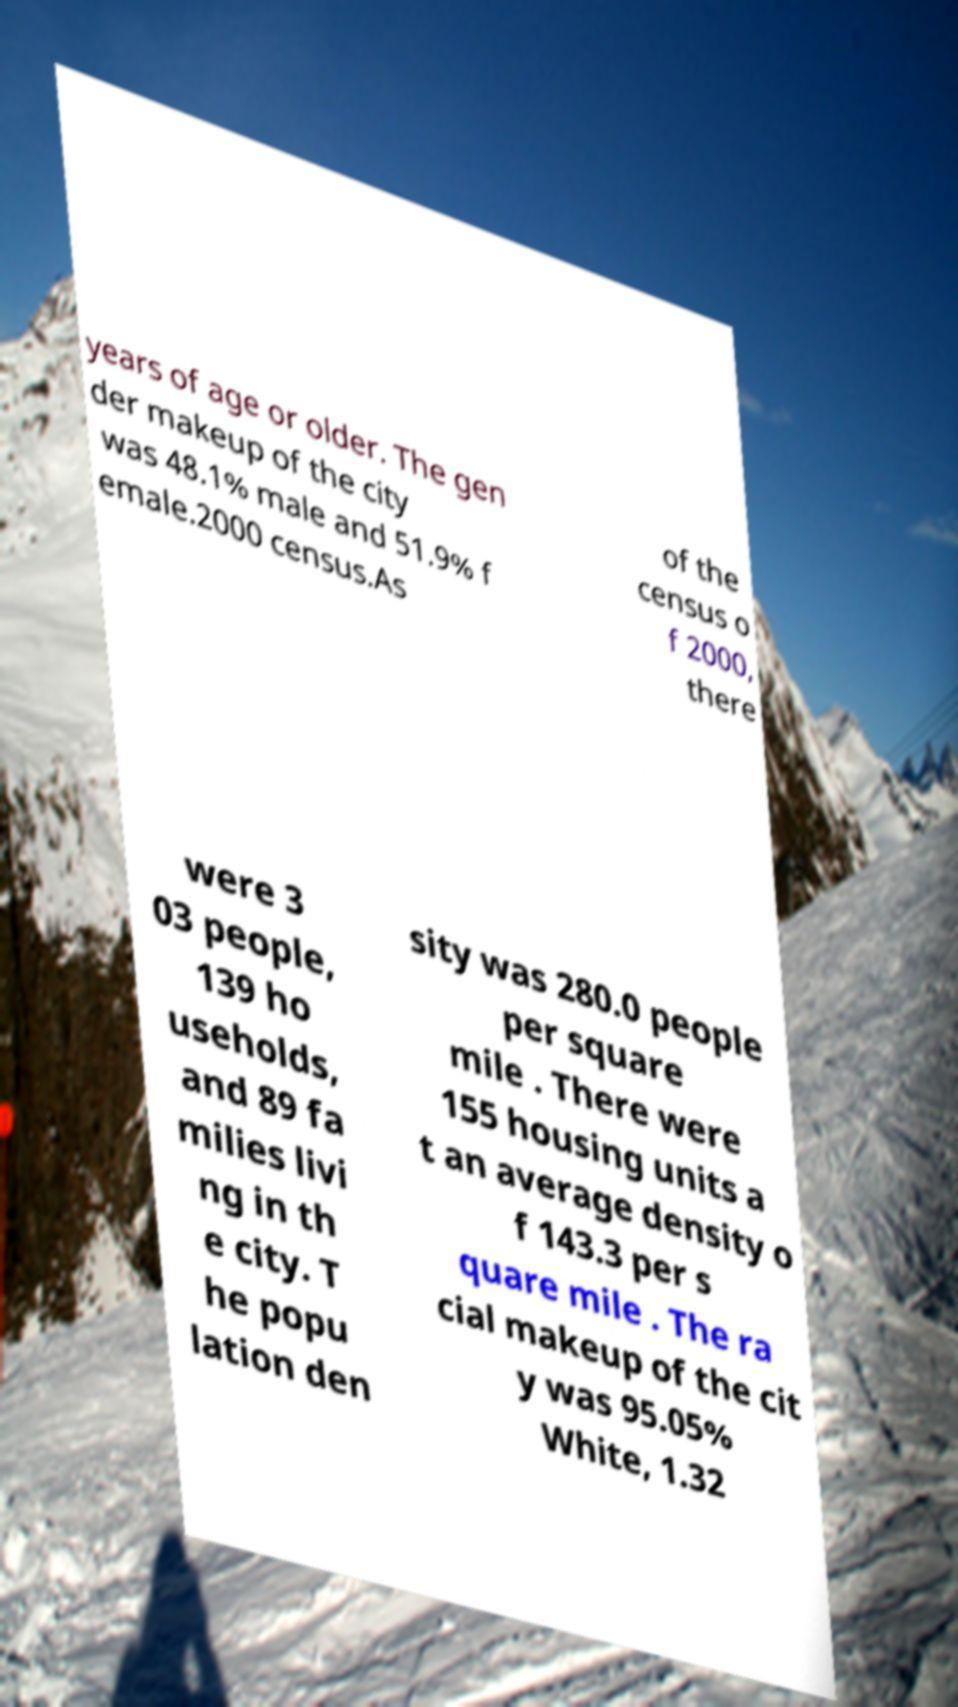Can you read and provide the text displayed in the image?This photo seems to have some interesting text. Can you extract and type it out for me? years of age or older. The gen der makeup of the city was 48.1% male and 51.9% f emale.2000 census.As of the census o f 2000, there were 3 03 people, 139 ho useholds, and 89 fa milies livi ng in th e city. T he popu lation den sity was 280.0 people per square mile . There were 155 housing units a t an average density o f 143.3 per s quare mile . The ra cial makeup of the cit y was 95.05% White, 1.32 